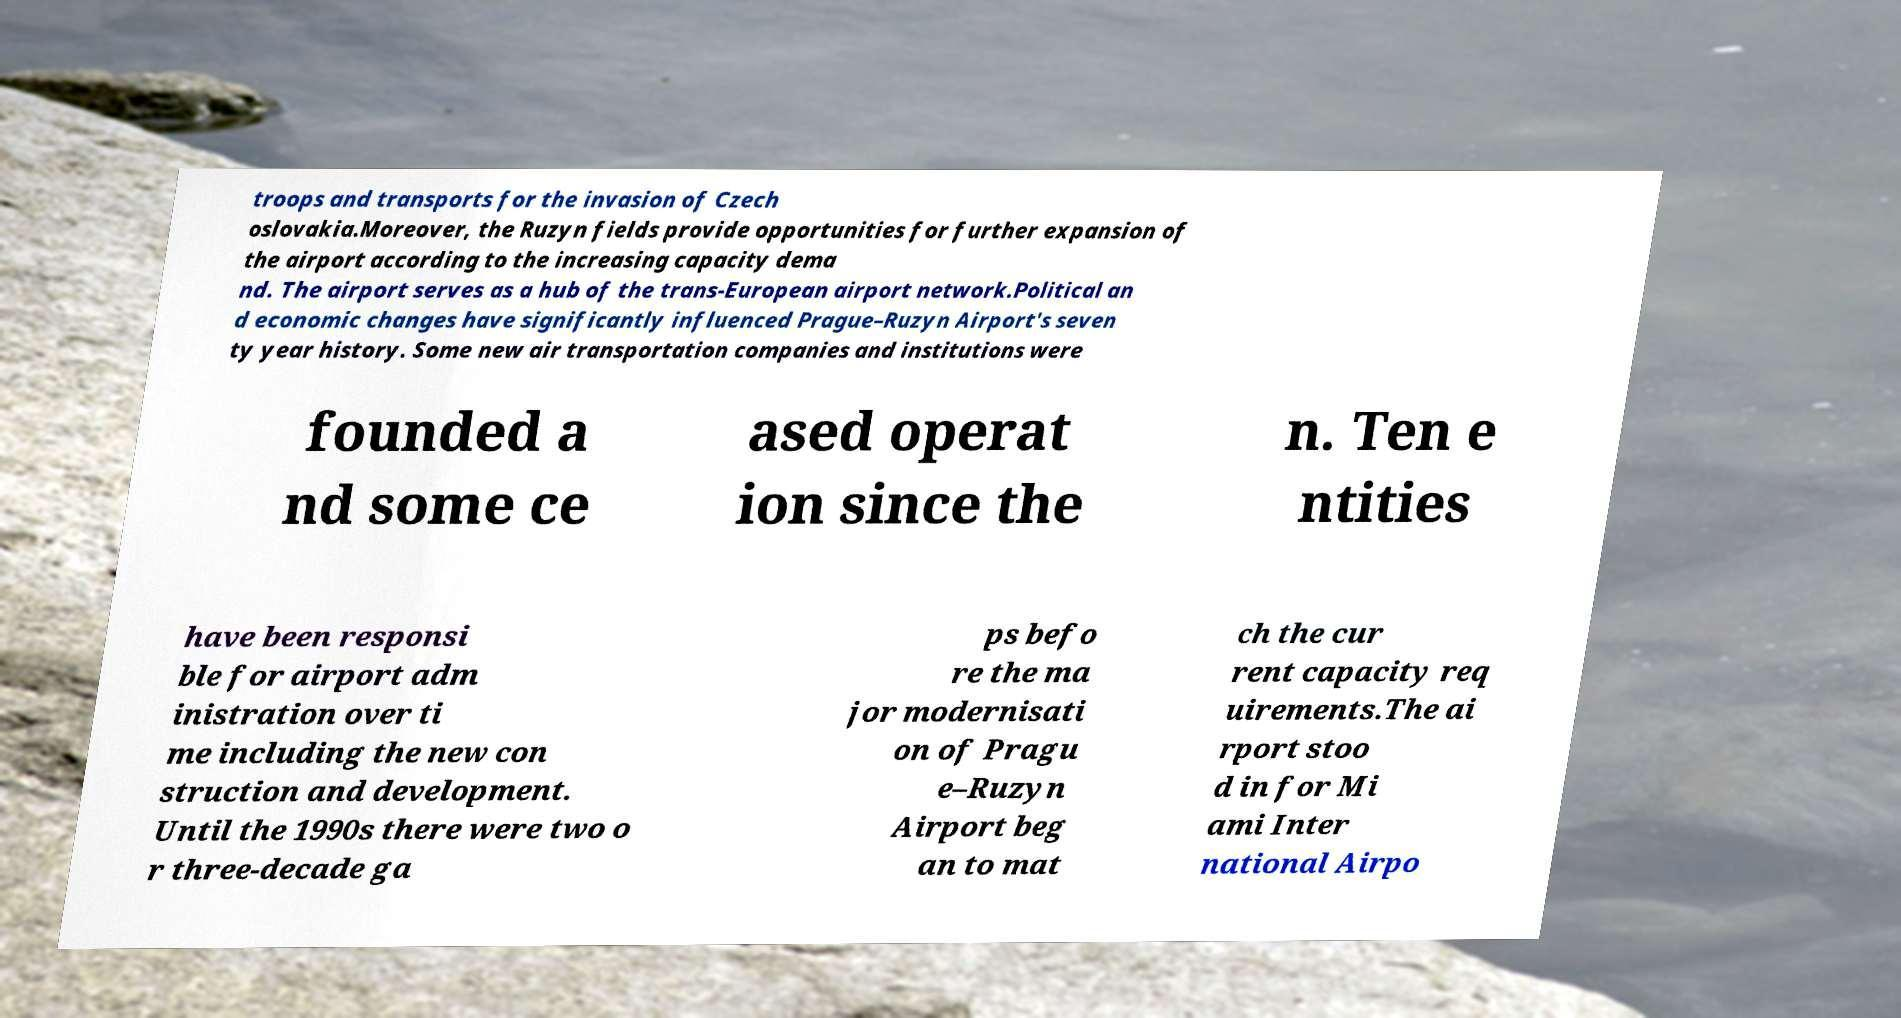Please identify and transcribe the text found in this image. troops and transports for the invasion of Czech oslovakia.Moreover, the Ruzyn fields provide opportunities for further expansion of the airport according to the increasing capacity dema nd. The airport serves as a hub of the trans-European airport network.Political an d economic changes have significantly influenced Prague–Ruzyn Airport's seven ty year history. Some new air transportation companies and institutions were founded a nd some ce ased operat ion since the n. Ten e ntities have been responsi ble for airport adm inistration over ti me including the new con struction and development. Until the 1990s there were two o r three-decade ga ps befo re the ma jor modernisati on of Pragu e–Ruzyn Airport beg an to mat ch the cur rent capacity req uirements.The ai rport stoo d in for Mi ami Inter national Airpo 